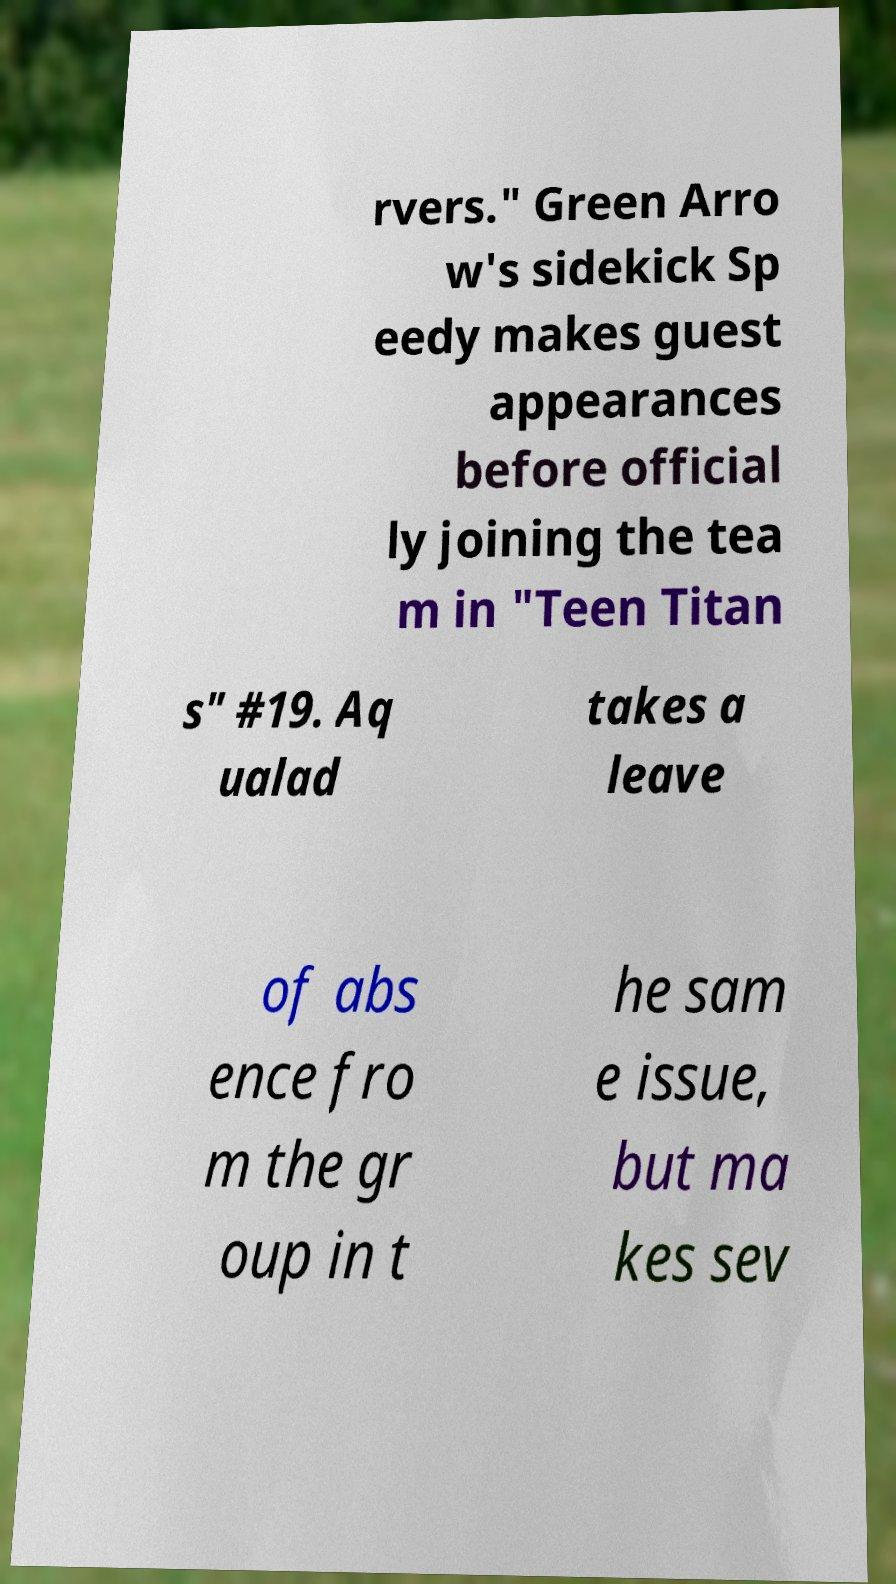I need the written content from this picture converted into text. Can you do that? rvers." Green Arro w's sidekick Sp eedy makes guest appearances before official ly joining the tea m in "Teen Titan s" #19. Aq ualad takes a leave of abs ence fro m the gr oup in t he sam e issue, but ma kes sev 